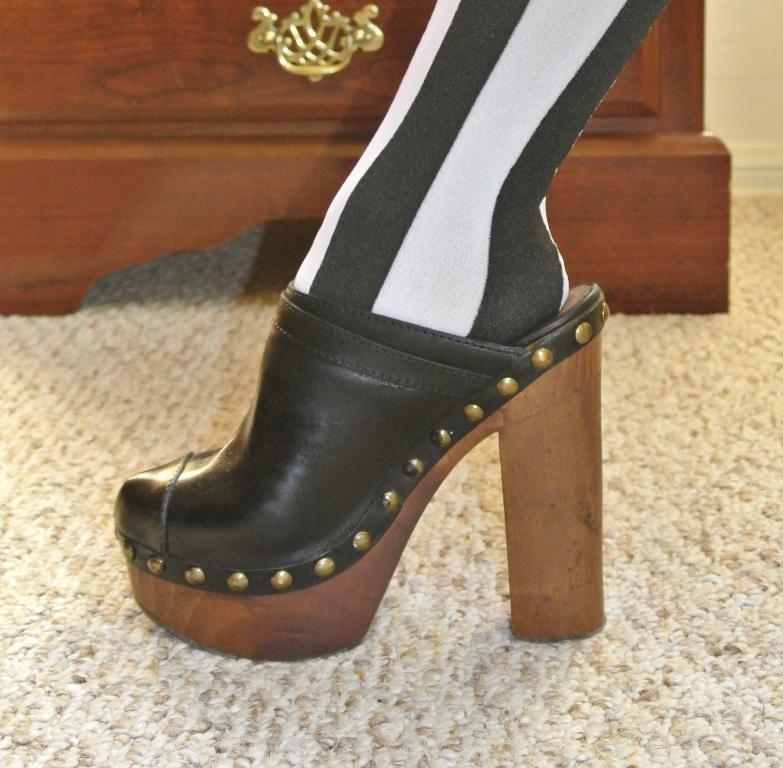Can you describe this image briefly? this is a zoomed in picture. In the center we can see the leg of a person wearing heel. In the background there is a wooden object and the ground is covered with the floor mat. 